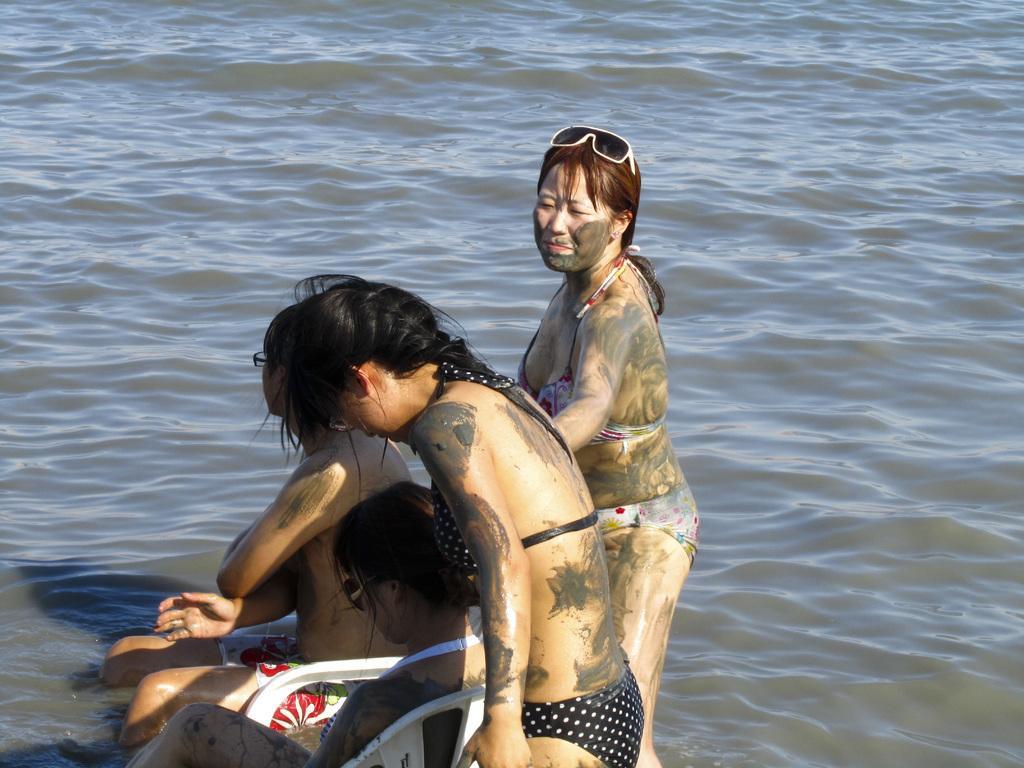Can you describe this image briefly? As we can see in the image there is water and four women over here. These two are standing and these two women are sitting on chairs. 